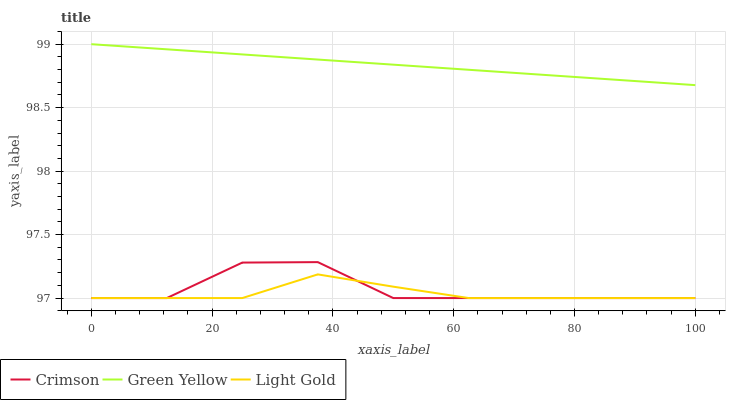Does Light Gold have the minimum area under the curve?
Answer yes or no. Yes. Does Green Yellow have the maximum area under the curve?
Answer yes or no. Yes. Does Green Yellow have the minimum area under the curve?
Answer yes or no. No. Does Light Gold have the maximum area under the curve?
Answer yes or no. No. Is Green Yellow the smoothest?
Answer yes or no. Yes. Is Crimson the roughest?
Answer yes or no. Yes. Is Light Gold the smoothest?
Answer yes or no. No. Is Light Gold the roughest?
Answer yes or no. No. Does Crimson have the lowest value?
Answer yes or no. Yes. Does Green Yellow have the lowest value?
Answer yes or no. No. Does Green Yellow have the highest value?
Answer yes or no. Yes. Does Light Gold have the highest value?
Answer yes or no. No. Is Light Gold less than Green Yellow?
Answer yes or no. Yes. Is Green Yellow greater than Crimson?
Answer yes or no. Yes. Does Crimson intersect Light Gold?
Answer yes or no. Yes. Is Crimson less than Light Gold?
Answer yes or no. No. Is Crimson greater than Light Gold?
Answer yes or no. No. Does Light Gold intersect Green Yellow?
Answer yes or no. No. 